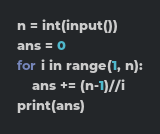Convert code to text. <code><loc_0><loc_0><loc_500><loc_500><_Python_>n = int(input())
ans = 0
for i in range(1, n):
	ans += (n-1)//i
print(ans)</code> 